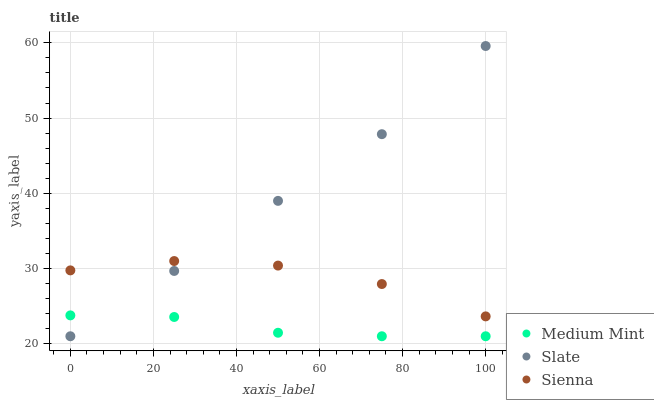Does Medium Mint have the minimum area under the curve?
Answer yes or no. Yes. Does Slate have the maximum area under the curve?
Answer yes or no. Yes. Does Sienna have the minimum area under the curve?
Answer yes or no. No. Does Sienna have the maximum area under the curve?
Answer yes or no. No. Is Slate the smoothest?
Answer yes or no. Yes. Is Sienna the roughest?
Answer yes or no. Yes. Is Sienna the smoothest?
Answer yes or no. No. Is Slate the roughest?
Answer yes or no. No. Does Medium Mint have the lowest value?
Answer yes or no. Yes. Does Sienna have the lowest value?
Answer yes or no. No. Does Slate have the highest value?
Answer yes or no. Yes. Does Sienna have the highest value?
Answer yes or no. No. Is Medium Mint less than Sienna?
Answer yes or no. Yes. Is Sienna greater than Medium Mint?
Answer yes or no. Yes. Does Slate intersect Sienna?
Answer yes or no. Yes. Is Slate less than Sienna?
Answer yes or no. No. Is Slate greater than Sienna?
Answer yes or no. No. Does Medium Mint intersect Sienna?
Answer yes or no. No. 